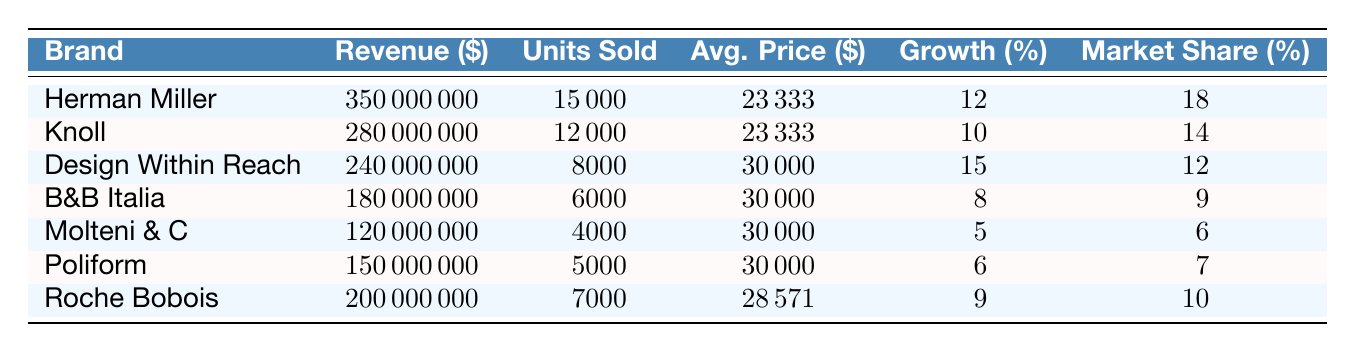What is the revenue of Herman Miller? The table shows that Herman Miller has a revenue listed as 350000000.
Answer: 350000000 Which brand had the highest market share? Herman Miller has the highest market share of 18%, compared to other brands listed.
Answer: Herman Miller What is the average price of furniture sold by Design Within Reach? The average price for Design Within Reach is listed in the table as 30000.
Answer: 30000 How much total revenue did the brands achieve together? The total revenue is the sum of the individual revenues: 350000000 + 280000000 + 240000000 + 180000000 + 120000000 + 150000000 + 200000000 = 1,620,000,000.
Answer: 1620000000 Is the growth rate of Poliform greater than 10%? Poliform has a growth rate of 6%, which is not greater than 10%.
Answer: No Which brand has the highest average price per unit? Design Within Reach has the highest average price at 30000, compared to the other brands.
Answer: Design Within Reach If we consider the average of the revenue of the brands, what is it? To find the average revenue, sum the revenues (350000000 + 280000000 + 240000000 + 180000000 + 120000000 + 150000000 + 200000000 = 1,620,000,000) and divide by the number of brands (7). Thus, average revenue = 1620000000 / 7 = 231428571.43.
Answer: 231428571.43 How many units did Knoll sell? The number of units sold by Knoll is shown in the table as 12000.
Answer: 12000 Does B&B Italia have a higher revenue than Roche Bobois? B&B Italia's revenue is 180000000 while Roche Bobois' is 200000000, thus B&B Italia does not have higher revenue.
Answer: No 